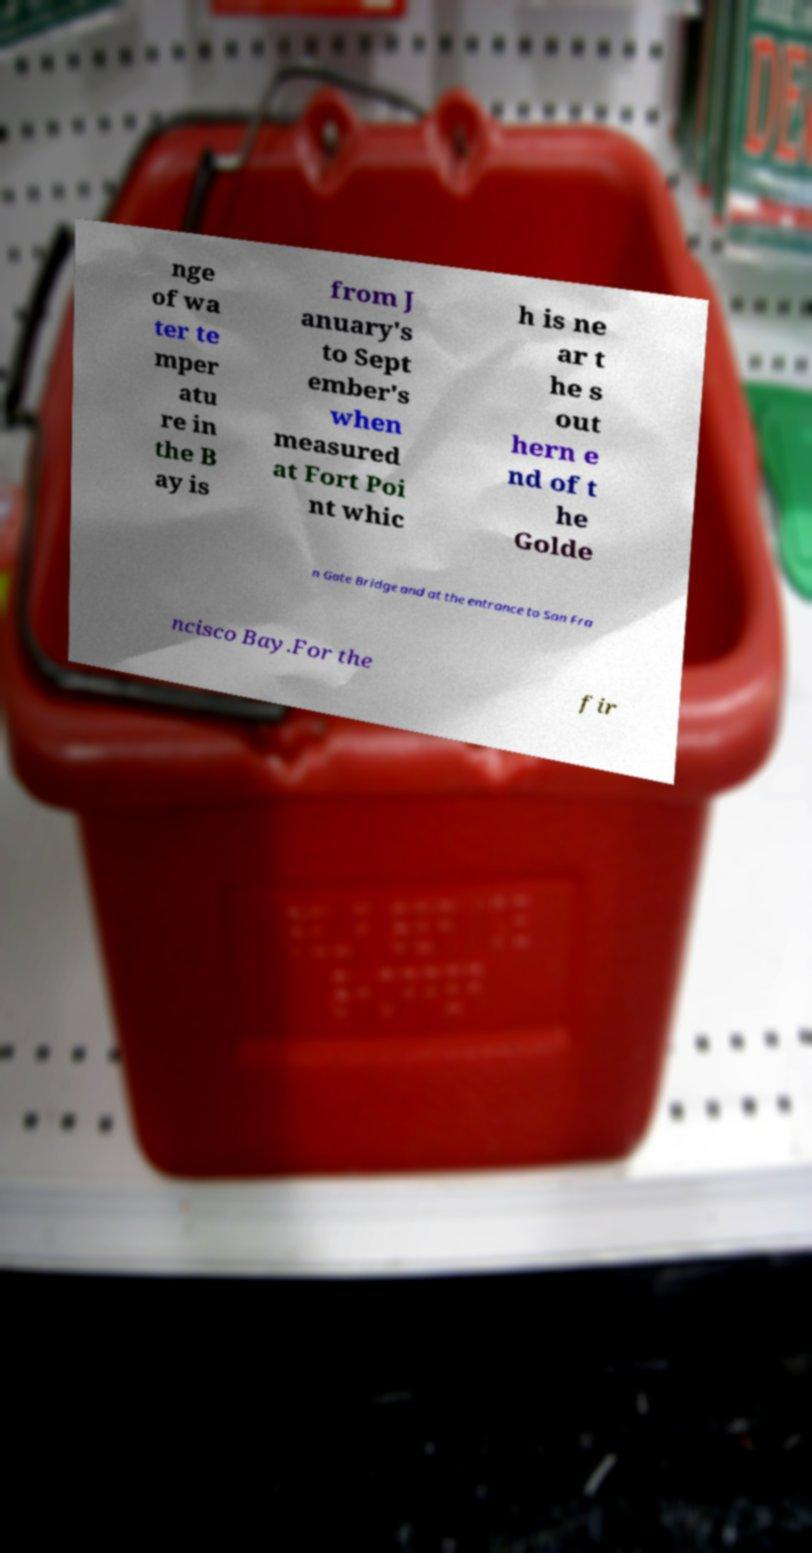Can you read and provide the text displayed in the image?This photo seems to have some interesting text. Can you extract and type it out for me? nge of wa ter te mper atu re in the B ay is from J anuary's to Sept ember's when measured at Fort Poi nt whic h is ne ar t he s out hern e nd of t he Golde n Gate Bridge and at the entrance to San Fra ncisco Bay.For the fir 